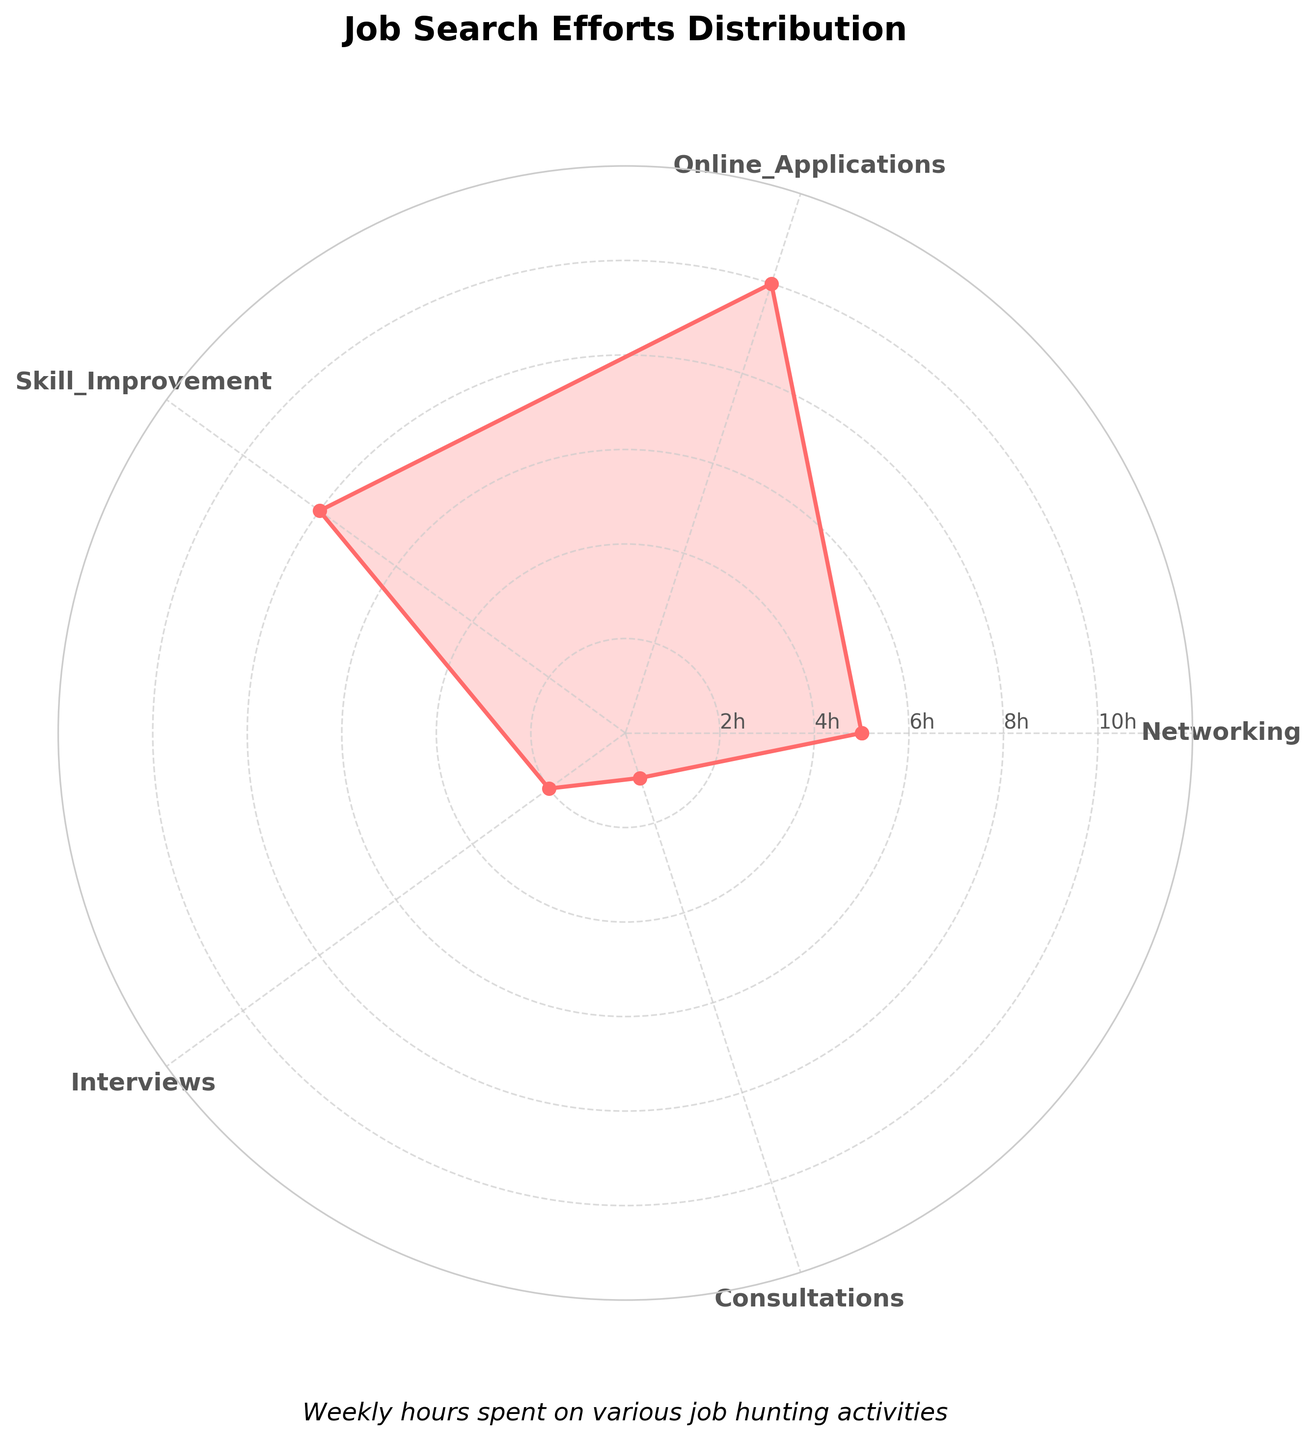what is the title of the chart? The title of the chart is displayed at the top center of the radar chart. It provides a brief description of the chart's content.
Answer: Job Search Efforts Distribution How many hours are spent weekly on online applications? Look at the "Online Applications" category on the radar chart. The value corresponding to this category represents the weekly hours spent.
Answer: 10 hours What activity has the least amount of time spent weekly? Check the values around the radar chart and find the category with the lowest value. The category with the smallest area on the chart will have the least time spent.
Answer: Consultations How many hours in total are spent weekly on job search activities? Add up the hours from all categories presented in the radar chart. (Networking: 5, Online Applications: 10, Skill Improvement: 8, Interviews: 2, Consultations: 1) Total = 5 + 10 + 8 + 2 + 1
Answer: 26 hours How does the time spent on skill improvement compare to the time spent on interviews? Look at the values for "Skill Improvement" and "Interviews". Determine which value is greater and by how much. Skill Improvement: 8, Interviews: 2, Difference = 8 - 2
Answer: 6 hours more on skill improvement Which two categories have a combined time spent of 9 hours weekly? Look at the chart and identify pairs of categories whose values sum up to 9. Adding different pairs: Networking (5) + Interviews (2), Networking (5) + Consultations (1), Online Applications (10), etc. Only Interviews and Consultations sum up to 9 hours logically.
Answer: Interviews and Networking What is the average time spent per week on all the activities? Sum up all the hours spent on each activity and divide by the number of activities. (Total hours = 26, Number of activities = 5) Average = 26 / 5
Answer: 5.2 hours Which job hunting activity has the second-highest amount of time spent weekly? Identify the activity with the second-largest value on the radar chart, which is just below the highest. Highest value: Online Applications (10), second highest: Skill Improvement
Answer: Skill Improvement In which category is the time spent closest to the average weekly time spent? Calculate the average weekly time spent (5.2 hours) and compare it to each category's value. The category closest to 5.2 hours will be the answer. Average time (5.2 hours), Closest category comparison: Networking (5), Online Applications (10), Skill Improvement (8), Interviews (2), Consultations (1)
Answer: Networking 